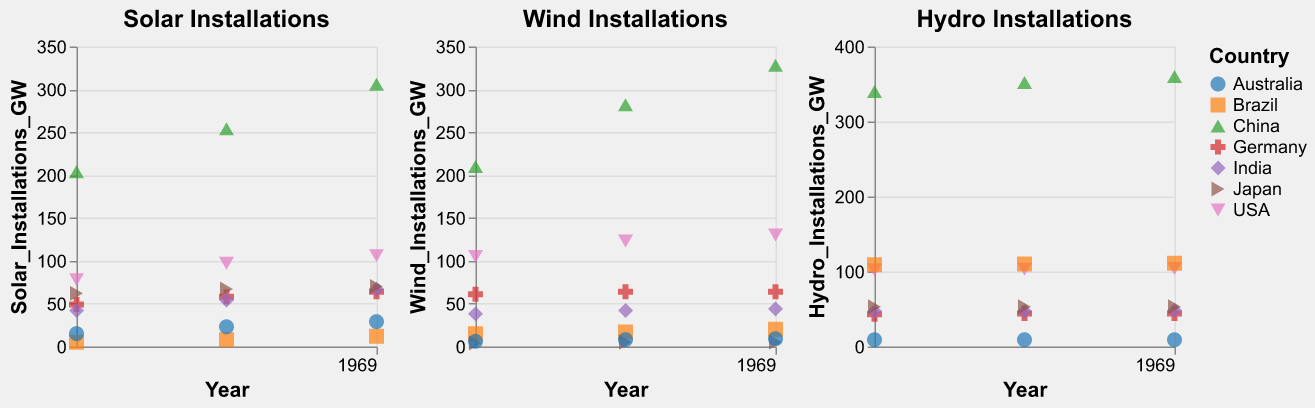What is the title of the subplot for solar installations? The title can be found at the top of the first subplot. It reads "Solar Installations".
Answer: Solar Installations Which country had the highest solar installations in 2021 according to the figure? By looking at the Solar Installations subplot and finding the data point for 2021, the point for China is at the highest position on the y-axis, indicating the highest value.
Answer: China How has solar installation in the USA changed from 2019 to 2021? Observe the Solar Installations subplot for the USA's data points from 2019, 2020, and 2021. The values increase each year from 78 GW to 97 GW to 106 GW.
Answer: Increased Which country shows the least amount of wind installations in 2021? Look at the Wind Installations subplot for the data points at 2021. The point for Japan is the lowest on the y-axis, indicating the smallest value, which is 5 GW.
Answer: Japan Between which two countries is the difference in hydro installations minimal in 2021? By comparing the hydro installations for each country in 2021, Germany and India both have nearly the same values (44 GW and 48 GW respectively), resulting in the minimal difference of 4 GW.
Answer: Germany and India What trend can be observed from the hydro installations in China from 2019 to 2021? In the subplot for Hydro Installations for China, the data points show a slight increase in hydro installations from 340 GW in 2019 to 352 GW in 2020, and then to 360 GW in 2021.
Answer: Increasing trend How does Brazil's wind installations in 2020 compare to Australia's in 2020? In the Wind Installations subplot, the y-axis values for Brazil in 2020 show 17 GW, while for Australia, it shows 8 GW in 2020. Brazil has more wind installations compared to Australia in that year.
Answer: Brazil has more wind installations What is the average solar installation in Germany from 2019 to 2021? Find the solar installation values for Germany in 2019, 2020, and 2021, which are 49 GW, 58 GW, and 64 GW respectively. The calculation for the average is (49 + 58 + 64) / 3 = 57 GW.
Answer: 57 GW How many countries achieved over 50 GW solar installations in 2021? Check each country's data point in the Solar Installations subplot for the year 2021. The countries that surpassed 50 GW are China, USA, Germany, India, and Japan.
Answer: 5 countries Which country's wind installations remained constant from 2020 to 2021? Look at the Wind Installations subplot. Find the country where the y-values for 2020 and 2021 are the same. Germany maintained constant installations at 64 GW.
Answer: Germany 